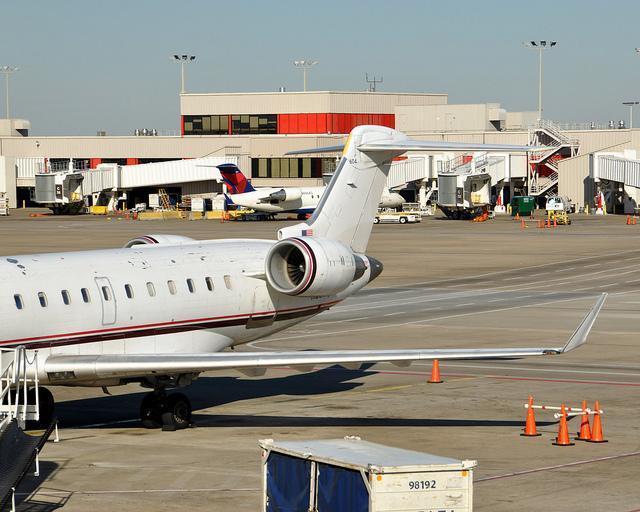How many airplanes are there?
Give a very brief answer. 2. 